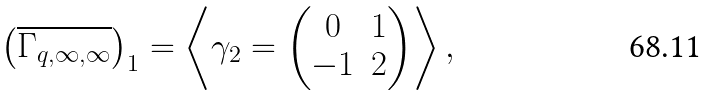<formula> <loc_0><loc_0><loc_500><loc_500>\left ( \overline { \Gamma _ { q , \infty , \infty } } \right ) _ { 1 } = \left \langle \gamma _ { 2 } = \begin{pmatrix} 0 & 1 \\ - 1 & 2 \end{pmatrix} \right \rangle ,</formula> 